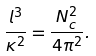<formula> <loc_0><loc_0><loc_500><loc_500>\frac { l ^ { 3 } } { \kappa ^ { 2 } } = \frac { N _ { c } ^ { 2 } } { 4 \pi ^ { 2 } } .</formula> 